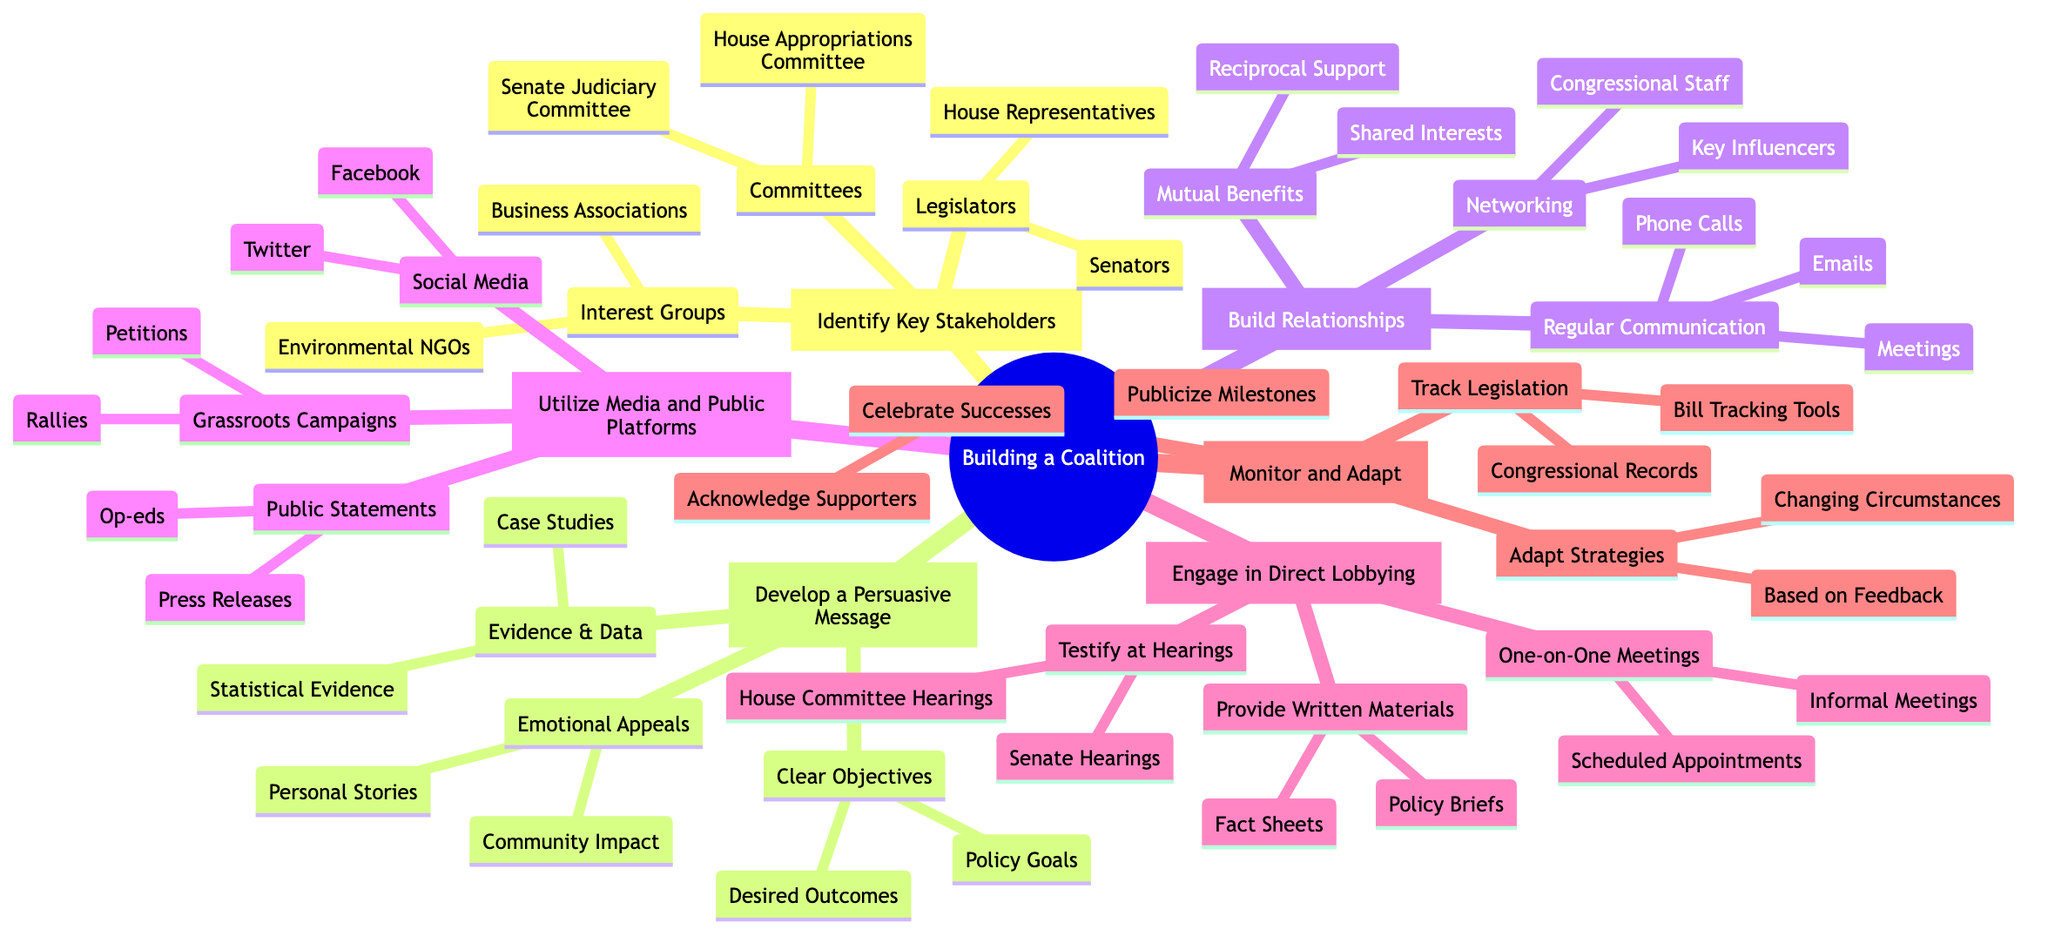What is the first strategy in building a coalition? The first strategy identified in the diagram is "Identify Key Stakeholders," which is directly represented as the first numbered node.
Answer: Identify Key Stakeholders How many sub-elements does "Develop a Persuasive Message" have? The node "Develop a Persuasive Message" contains three sub-elements: "Clear Objectives," "Evidence & Data," and "Emotional Appeals," which can be counted.
Answer: 3 Which interest group is mentioned under "Identify Key Stakeholders"? Under "Identify Key Stakeholders," one of the listed interest groups is "Environmental NGOs," which is explicitly stated as a sub-element.
Answer: Environmental NGOs What platforms are suggested under "Utilize Media and Public Platforms"? The sub-elements listed under this node include "Social Media," "Public Statements," and "Grassroots Campaigns," which outline different platforms for media utilization.
Answer: Social Media, Public Statements, Grassroots Campaigns What type of meetings are included in the "Engage in Direct Lobbying" strategy? The section "Engage in Direct Lobbying" specifically mentions two types of meetings: "One-on-One Meetings" and "Testify at Hearings," detailing the direct engagement methods.
Answer: One-on-One Meetings, Testify at Hearings How many main strategies are outlined in the mind map? The main strategies are numbered from 1 to 6 in the diagram, indicating the number of distinct strategies presented for lobbying support in Congress.
Answer: 6 What should be tracked according to the "Monitor and Adapt" strategy? The sub-element "Track Legislation" suggests the need to monitor existing laws, represented explicitly under the "Monitor and Adapt" strategy.
Answer: Track Legislation What is a suggested method for building relationships? The strategy includes "Networking" as a method for building relationships, which indicates the importance of personal connections in lobbying efforts.
Answer: Networking 